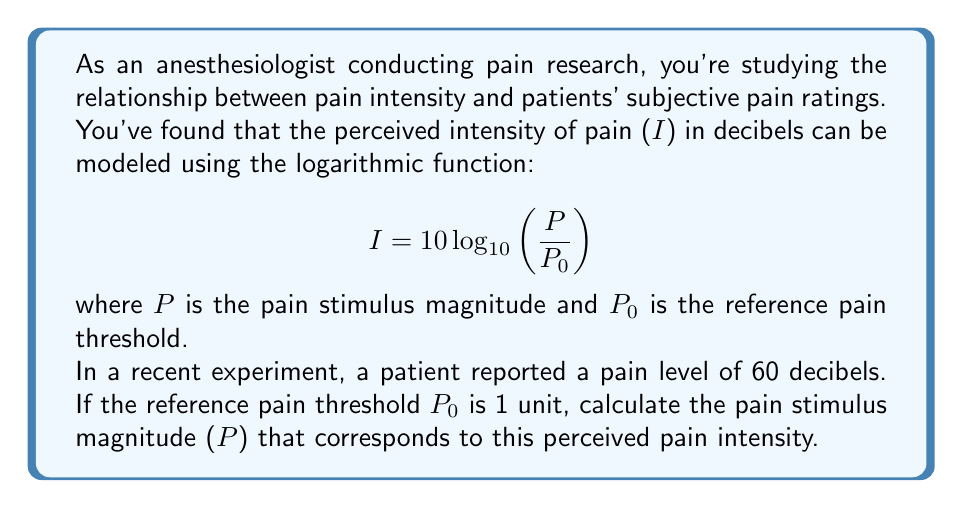Can you answer this question? Let's approach this step-by-step:

1) We're given the logarithmic function for pain intensity:

   $$I = 10 \log_{10}\left(\frac{P}{P_0}\right)$$

2) We know that:
   - I = 60 decibels (the reported pain level)
   - $P_0$ = 1 unit (the reference pain threshold)
   - We need to find P (the pain stimulus magnitude)

3) Let's substitute the known values into the equation:

   $$60 = 10 \log_{10}\left(\frac{P}{1}\right)$$

4) Simplify:

   $$60 = 10 \log_{10}(P)$$

5) Divide both sides by 10:

   $$6 = \log_{10}(P)$$

6) To solve for P, we need to apply the inverse function of $\log_{10}$, which is $10^x$:

   $$10^6 = 10^{\log_{10}(P)}$$

7) The left side simplifies to $10^6$, and on the right side, the $10^{\log_{10}}$ cancels out:

   $$10^6 = P$$

8) Calculate the result:

   $$P = 1,000,000$$

Therefore, the pain stimulus magnitude that corresponds to a perceived pain intensity of 60 decibels is 1,000,000 units.
Answer: $P = 1,000,000$ units 